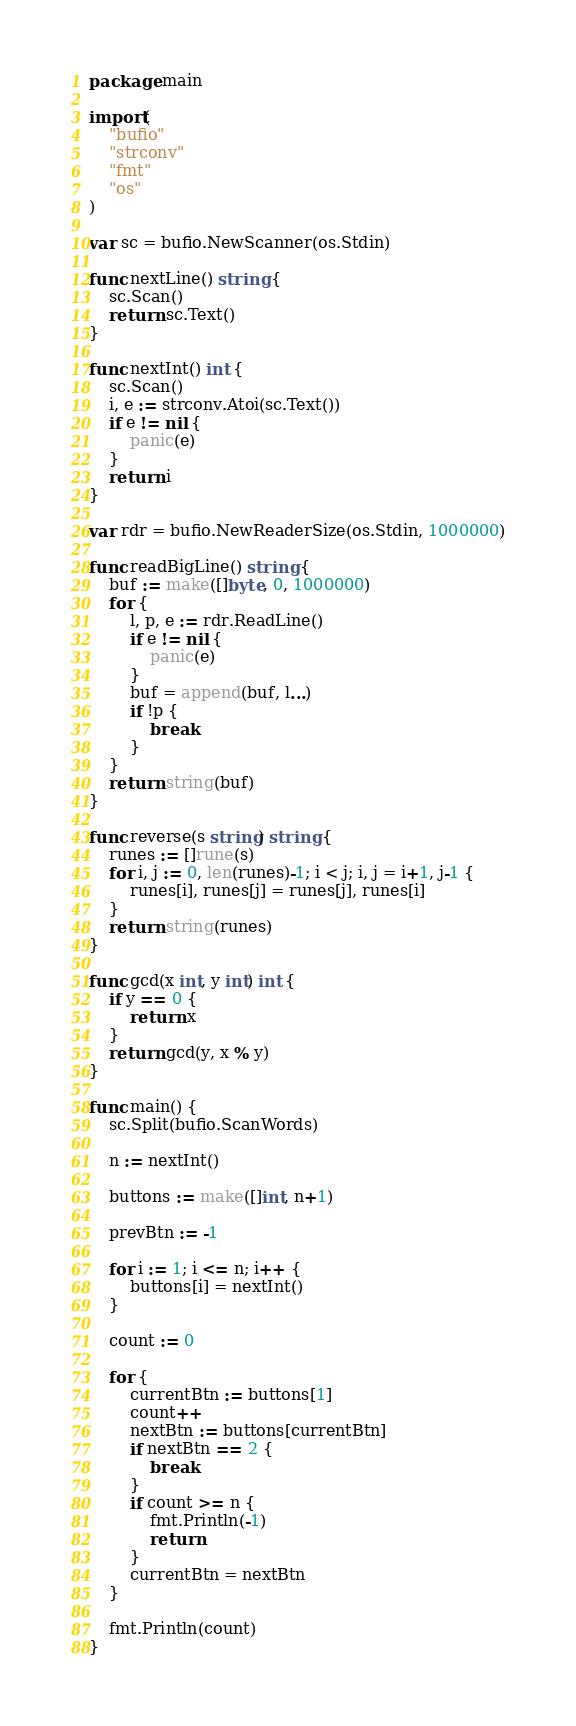Convert code to text. <code><loc_0><loc_0><loc_500><loc_500><_Go_>package main

import(
	"bufio"
	"strconv"
	"fmt"
	"os"
)

var sc = bufio.NewScanner(os.Stdin)

func nextLine() string {
	sc.Scan()
	return sc.Text()
}

func nextInt() int {
	sc.Scan()
	i, e := strconv.Atoi(sc.Text())
	if e != nil {
		panic(e)
	}
	return i
}

var rdr = bufio.NewReaderSize(os.Stdin, 1000000)

func readBigLine() string {
	buf := make([]byte, 0, 1000000)
	for {
		l, p, e := rdr.ReadLine()
		if e != nil {
			panic(e)
		}
		buf = append(buf, l...)
		if !p {
			break
		}
	}
	return string(buf)
}

func reverse(s string) string {
	runes := []rune(s)
	for i, j := 0, len(runes)-1; i < j; i, j = i+1, j-1 {
		runes[i], runes[j] = runes[j], runes[i]
	}
	return string(runes)
}

func gcd(x int, y int) int {
	if y == 0 {
		return x
	}
	return gcd(y, x % y)
}

func main() {
	sc.Split(bufio.ScanWords)

	n := nextInt()

	buttons := make([]int, n+1)

	prevBtn := -1

	for i := 1; i <= n; i++ {
		buttons[i] = nextInt()
	}

	count := 0
	
	for {
		currentBtn := buttons[1]
		count++
		nextBtn := buttons[currentBtn]
		if nextBtn == 2 {
			break
		}
		if count >= n {
			fmt.Println(-1)
			return
		}
		currentBtn = nextBtn
	}
	
	fmt.Println(count)
}
</code> 